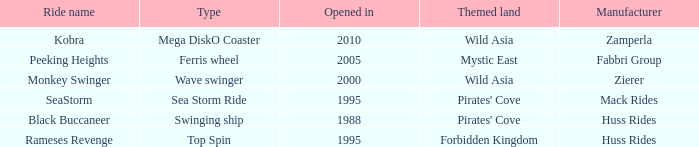What type ride is Wild Asia that opened in 2000? Wave swinger. 